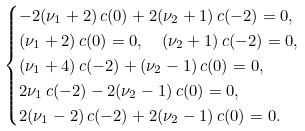Convert formula to latex. <formula><loc_0><loc_0><loc_500><loc_500>& \begin{cases} - 2 ( \nu _ { 1 } + 2 ) \, c ( 0 ) + 2 ( \nu _ { 2 } + 1 ) \, c ( - 2 ) = 0 , \\ ( \nu _ { 1 } + 2 ) \, c ( 0 ) = 0 , \quad ( \nu _ { 2 } + 1 ) \, c ( - 2 ) = 0 , \\ ( \nu _ { 1 } + 4 ) \, c ( - 2 ) + ( \nu _ { 2 } - 1 ) \, c ( 0 ) = 0 , \\ 2 \nu _ { 1 } \, c ( - 2 ) - 2 ( \nu _ { 2 } - 1 ) \, c ( 0 ) = 0 , \\ 2 ( \nu _ { 1 } - 2 ) \, c ( - 2 ) + 2 ( \nu _ { 2 } - 1 ) \, c ( 0 ) = 0 . \end{cases}</formula> 